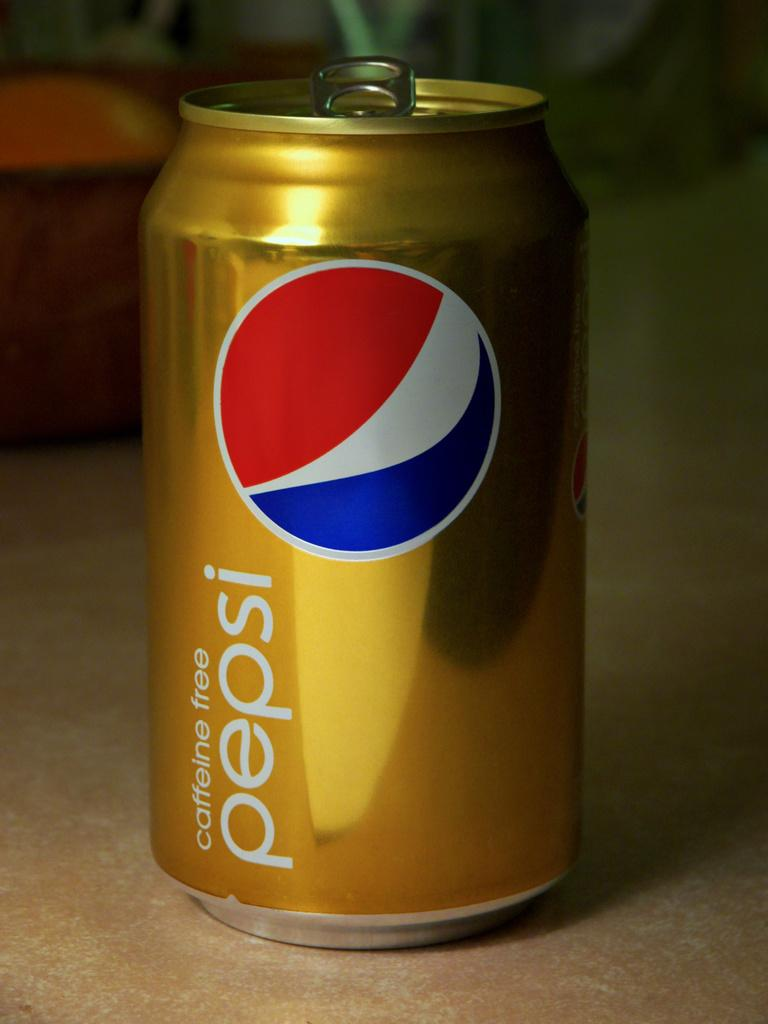<image>
Write a terse but informative summary of the picture. a Pepsi can that is on the table with a red, white and blue logo 